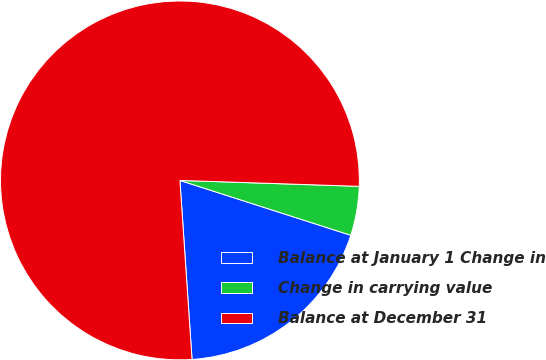Convert chart. <chart><loc_0><loc_0><loc_500><loc_500><pie_chart><fcel>Balance at January 1 Change in<fcel>Change in carrying value<fcel>Balance at December 31<nl><fcel>18.98%<fcel>4.42%<fcel>76.6%<nl></chart> 